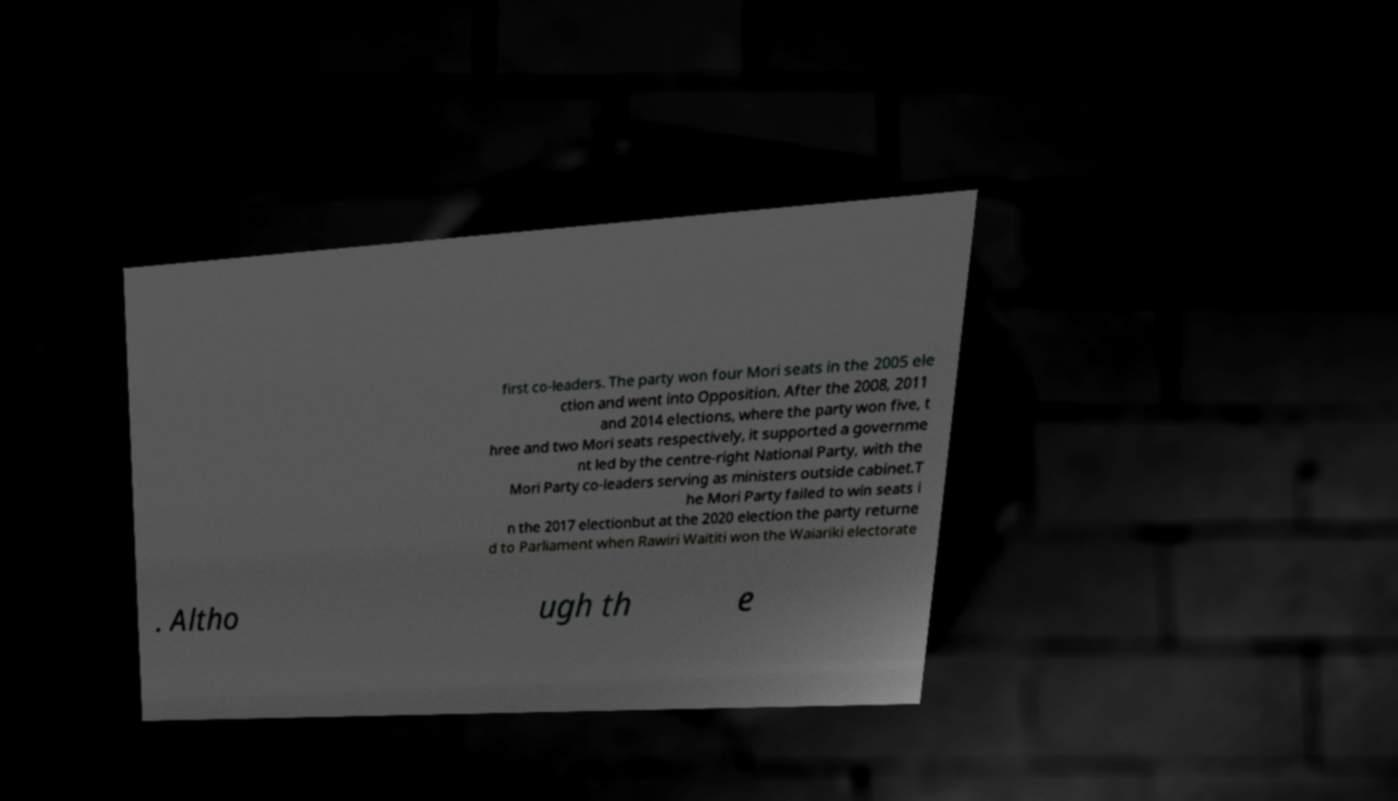Can you read and provide the text displayed in the image?This photo seems to have some interesting text. Can you extract and type it out for me? first co-leaders. The party won four Mori seats in the 2005 ele ction and went into Opposition. After the 2008, 2011 and 2014 elections, where the party won five, t hree and two Mori seats respectively, it supported a governme nt led by the centre-right National Party, with the Mori Party co-leaders serving as ministers outside cabinet.T he Mori Party failed to win seats i n the 2017 electionbut at the 2020 election the party returne d to Parliament when Rawiri Waititi won the Waiariki electorate . Altho ugh th e 